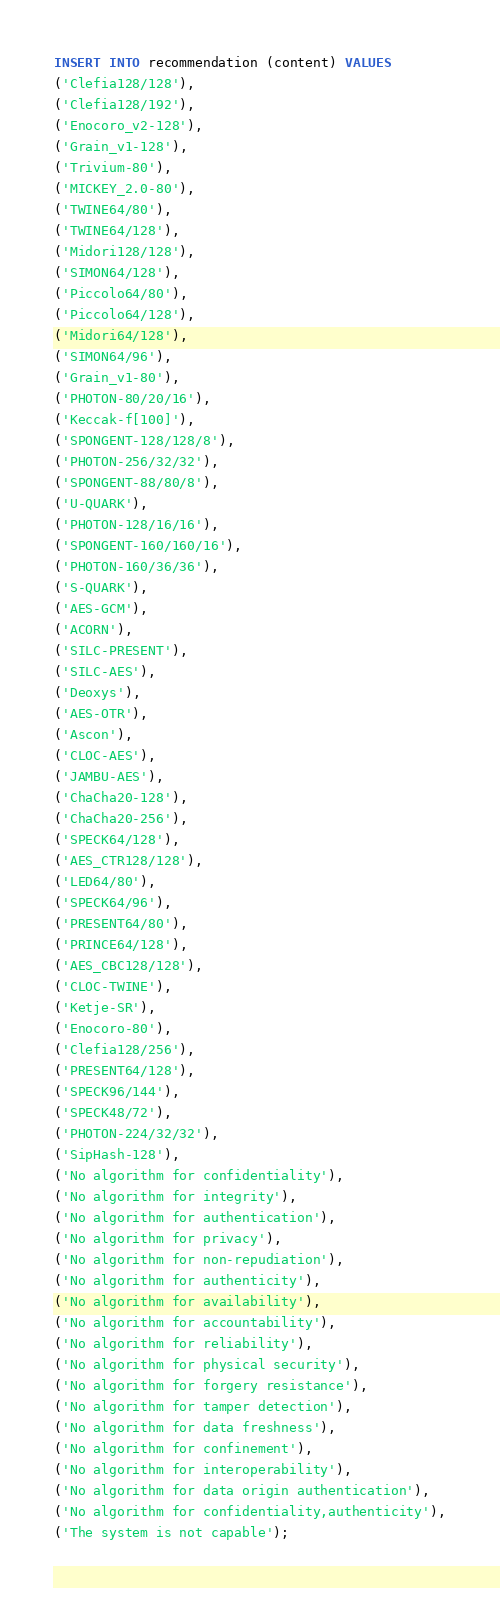<code> <loc_0><loc_0><loc_500><loc_500><_SQL_>INSERT INTO recommendation (content) VALUES 
('Clefia128/128'),
('Clefia128/192'),
('Enocoro_v2-128'),
('Grain_v1-128'),
('Trivium-80'),
('MICKEY_2.0-80'),
('TWINE64/80'),
('TWINE64/128'),
('Midori128/128'),
('SIMON64/128'),
('Piccolo64/80'),
('Piccolo64/128'),
('Midori64/128'),
('SIMON64/96'),
('Grain_v1-80'),
('PHOTON-80/20/16'),
('Keccak-f[100]'),
('SPONGENT-128/128/8'),
('PHOTON-256/32/32'),
('SPONGENT-88/80/8'),
('U-QUARK'),
('PHOTON-128/16/16'),
('SPONGENT-160/160/16'),
('PHOTON-160/36/36'),
('S-QUARK'),
('AES-GCM'),
('ACORN'),
('SILC-PRESENT'),
('SILC-AES'),
('Deoxys'),
('AES-OTR'),
('Ascon'),
('CLOC-AES'),
('JAMBU-AES'),
('ChaCha20-128'),
('ChaCha20-256'),
('SPECK64/128'),
('AES_CTR128/128'),
('LED64/80'),
('SPECK64/96'),
('PRESENT64/80'),
('PRINCE64/128'),
('AES_CBC128/128'),
('CLOC-TWINE'),
('Ketje-SR'),
('Enocoro-80'),
('Clefia128/256'),
('PRESENT64/128'),
('SPECK96/144'),
('SPECK48/72'),
('PHOTON-224/32/32'),
('SipHash-128'),
('No algorithm for confidentiality'),
('No algorithm for integrity'),
('No algorithm for authentication'),
('No algorithm for privacy'),
('No algorithm for non-repudiation'),
('No algorithm for authenticity'),
('No algorithm for availability'),
('No algorithm for accountability'),
('No algorithm for reliability'),
('No algorithm for physical security'),
('No algorithm for forgery resistance'),
('No algorithm for tamper detection'),
('No algorithm for data freshness'),
('No algorithm for confinement'),
('No algorithm for interoperability'),
('No algorithm for data origin authentication'),
('No algorithm for confidentiality,authenticity'),
('The system is not capable');</code> 